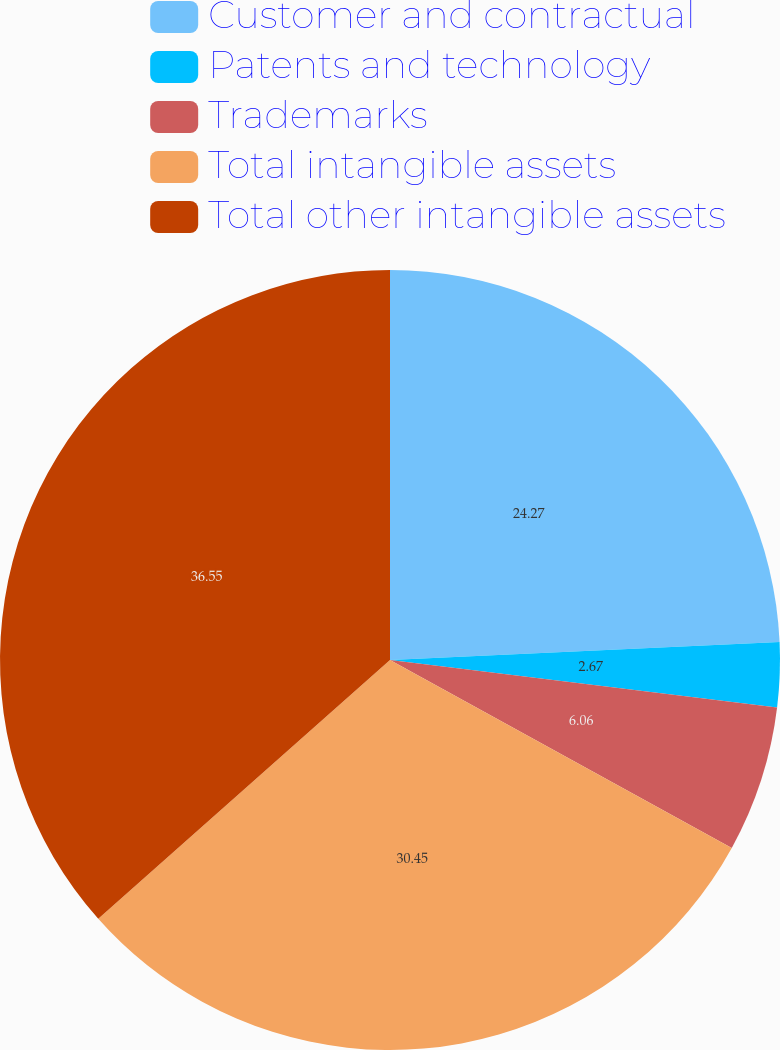Convert chart to OTSL. <chart><loc_0><loc_0><loc_500><loc_500><pie_chart><fcel>Customer and contractual<fcel>Patents and technology<fcel>Trademarks<fcel>Total intangible assets<fcel>Total other intangible assets<nl><fcel>24.27%<fcel>2.67%<fcel>6.06%<fcel>30.45%<fcel>36.55%<nl></chart> 